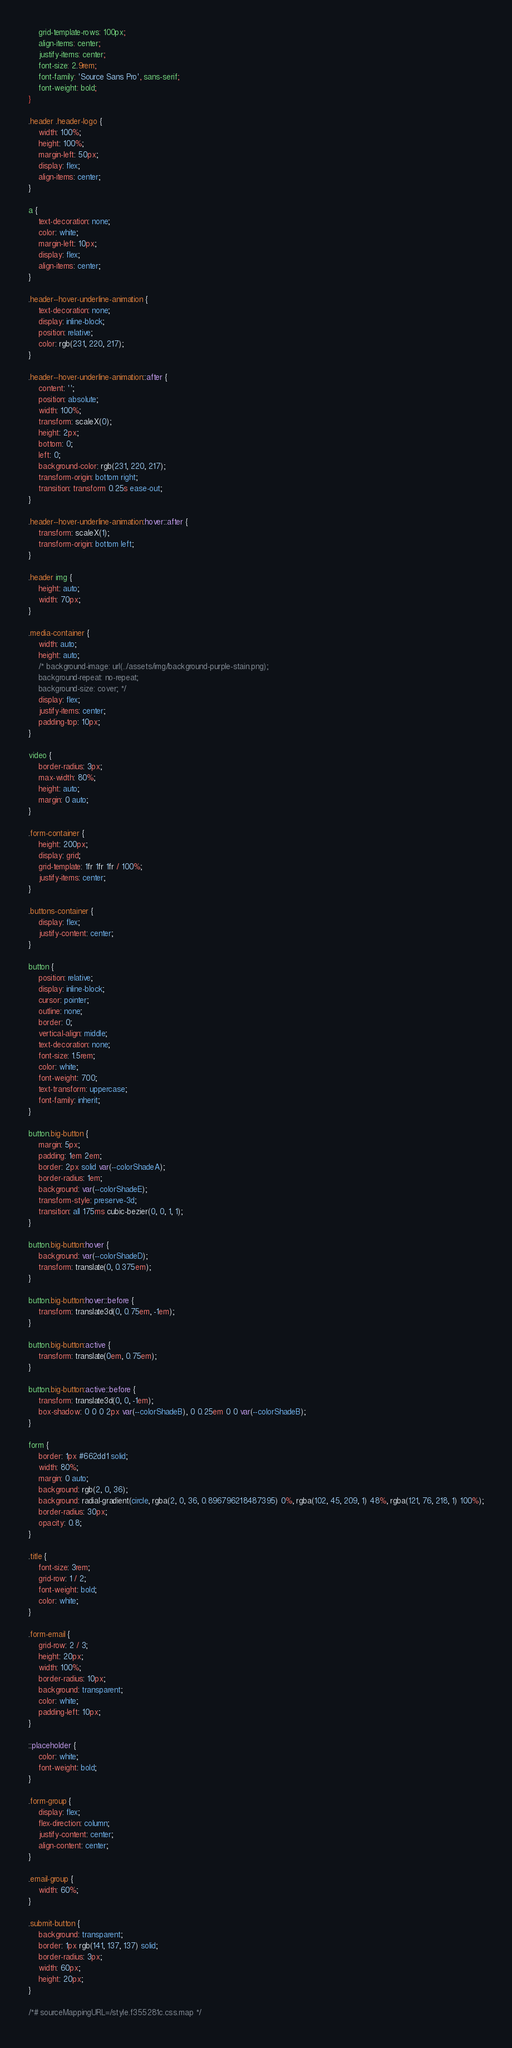Convert code to text. <code><loc_0><loc_0><loc_500><loc_500><_CSS_>    grid-template-rows: 100px;
    align-items: center;
    justify-items: center;
    font-size: 2.9rem;
    font-family: 'Source Sans Pro', sans-serif;
    font-weight: bold;
}

.header .header-logo {
    width: 100%;
    height: 100%;
    margin-left: 50px;
    display: flex;
    align-items: center;
}

a {
    text-decoration: none;
    color: white;
    margin-left: 10px;
    display: flex;
    align-items: center;
}

.header--hover-underline-animation {
    text-decoration: none;
    display: inline-block;
    position: relative;
    color: rgb(231, 220, 217);
}

.header--hover-underline-animation::after {
    content: '';
    position: absolute;
    width: 100%;
    transform: scaleX(0);
    height: 2px;
    bottom: 0;
    left: 0;
    background-color: rgb(231, 220, 217);
    transform-origin: bottom right;
    transition: transform 0.25s ease-out;
}

.header--hover-underline-animation:hover::after {
    transform: scaleX(1);
    transform-origin: bottom left;
}

.header img {
    height: auto;
    width: 70px;
}

.media-container {
    width: auto;
    height: auto;
    /* background-image: url(../assets/img/background-purple-stain.png);
    background-repeat: no-repeat;
    background-size: cover; */
    display: flex;
    justify-items: center;
    padding-top: 10px;
}

video {
    border-radius: 3px;
    max-width: 80%;
    height: auto;
    margin: 0 auto;
}

.form-container {
    height: 200px;
    display: grid;
    grid-template: 1fr 1fr 1fr / 100%;
    justify-items: center;
}

.buttons-container {
    display: flex;
    justify-content: center;
}

button {
    position: relative;
    display: inline-block;
    cursor: pointer;
    outline: none;
    border: 0;
    vertical-align: middle;
    text-decoration: none;
    font-size: 1.5rem;
    color: white;
    font-weight: 700;
    text-transform: uppercase;
    font-family: inherit;
}

button.big-button {
    margin: 5px;
    padding: 1em 2em;
    border: 2px solid var(--colorShadeA);
    border-radius: 1em;
    background: var(--colorShadeE);
    transform-style: preserve-3d;
    transition: all 175ms cubic-bezier(0, 0, 1, 1);
}

button.big-button:hover {
    background: var(--colorShadeD);
    transform: translate(0, 0.375em);
}

button.big-button:hover::before {
    transform: translate3d(0, 0.75em, -1em);
}

button.big-button:active {
    transform: translate(0em, 0.75em);
}

button.big-button:active::before {
    transform: translate3d(0, 0, -1em);
    box-shadow: 0 0 0 2px var(--colorShadeB), 0 0.25em 0 0 var(--colorShadeB);
}

form {
    border: 1px #662dd1 solid;
    width: 80%;
    margin: 0 auto;
    background: rgb(2, 0, 36);
    background: radial-gradient(circle, rgba(2, 0, 36, 0.896796218487395) 0%, rgba(102, 45, 209, 1) 48%, rgba(121, 76, 218, 1) 100%);
    border-radius: 30px;
    opacity: 0.8;
}

.title {
    font-size: 3rem;
    grid-row: 1 / 2;
    font-weight: bold;
    color: white;
}

.form-email {
    grid-row: 2 / 3;
    height: 20px;
    width: 100%;
    border-radius: 10px;
    background: transparent;
    color: white;
    padding-left: 10px;
}

::placeholder {
    color: white;
    font-weight: bold;
}

.form-group {
    display: flex;
    flex-direction: column;
    justify-content: center;
    align-content: center;
}

.email-group {
    width: 60%;
}

.submit-button {
    background: transparent;
    border: 1px rgb(141, 137, 137) solid;
    border-radius: 3px;
    width: 60px;
    height: 20px;
}

/*# sourceMappingURL=/style.f355281c.css.map */</code> 